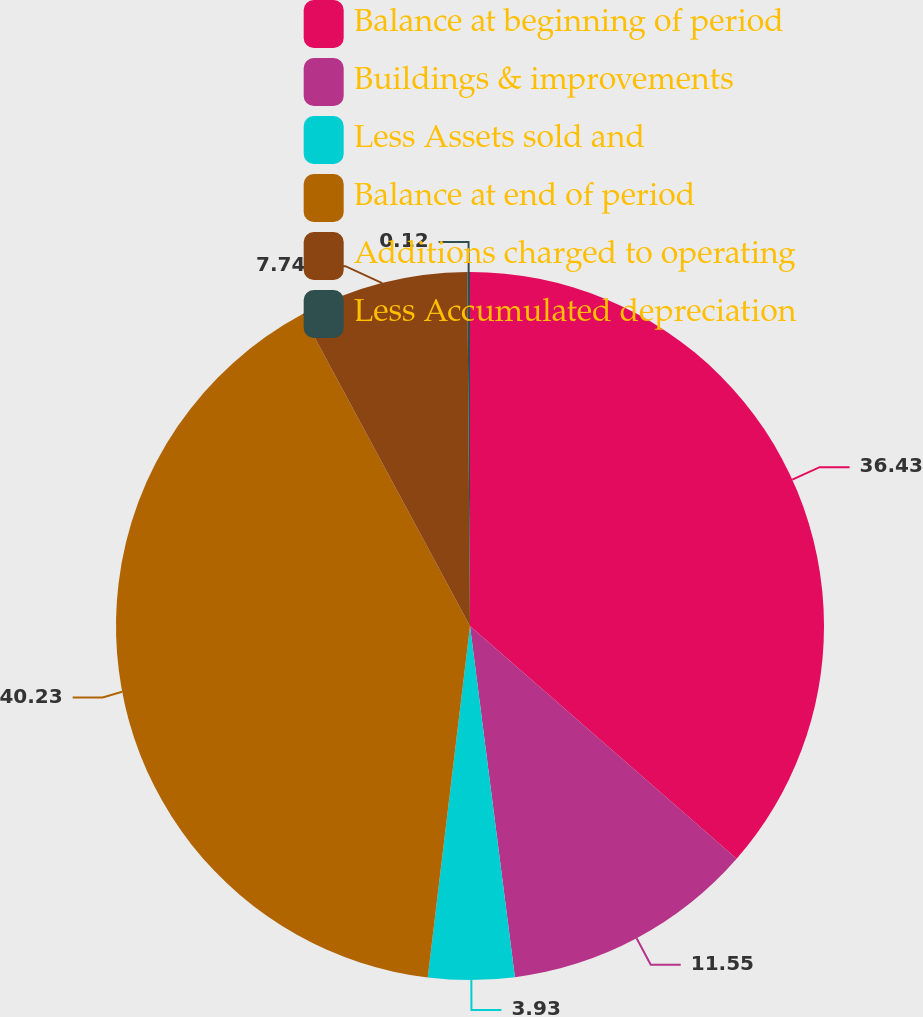<chart> <loc_0><loc_0><loc_500><loc_500><pie_chart><fcel>Balance at beginning of period<fcel>Buildings & improvements<fcel>Less Assets sold and<fcel>Balance at end of period<fcel>Additions charged to operating<fcel>Less Accumulated depreciation<nl><fcel>36.43%<fcel>11.55%<fcel>3.93%<fcel>40.24%<fcel>7.74%<fcel>0.12%<nl></chart> 